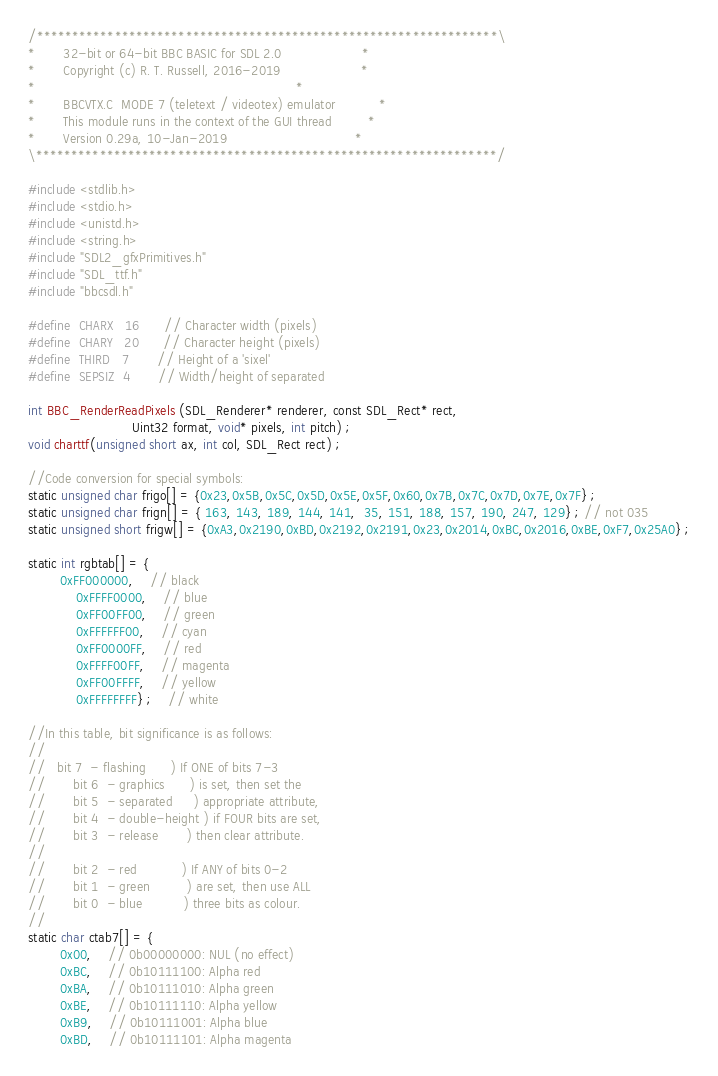<code> <loc_0><loc_0><loc_500><loc_500><_C_>/*****************************************************************\
*       32-bit or 64-bit BBC BASIC for SDL 2.0                    *
*       Copyright (c) R. T. Russell, 2016-2019                    *
*                                                                 *
*       BBCVTX.C  MODE 7 (teletext / videotex) emulator           *
*       This module runs in the context of the GUI thread         *
*       Version 0.29a, 10-Jan-2019                                *
\*****************************************************************/

#include <stdlib.h>
#include <stdio.h>
#include <unistd.h>
#include <string.h>
#include "SDL2_gfxPrimitives.h"
#include "SDL_ttf.h"
#include "bbcsdl.h"

#define	CHARX	16      // Character width (pixels)
#define	CHARY	20      // Character height (pixels)
#define	THIRD	7       // Height of a 'sixel'
#define	SEPSIZ	4       // Width/height of separated

int BBC_RenderReadPixels (SDL_Renderer* renderer, const SDL_Rect* rect,
                          Uint32 format, void* pixels, int pitch) ;
void charttf(unsigned short ax, int col, SDL_Rect rect) ;

//Code conversion for special symbols:
static unsigned char frigo[] = {0x23,0x5B,0x5C,0x5D,0x5E,0x5F,0x60,0x7B,0x7C,0x7D,0x7E,0x7F} ;
static unsigned char frign[] = { 163, 143, 189, 144, 141,  35, 151, 188, 157, 190, 247, 129} ; // not 035
static unsigned short frigw[] = {0xA3,0x2190,0xBD,0x2192,0x2191,0x23,0x2014,0xBC,0x2016,0xBE,0xF7,0x25A0} ;

static int rgbtab[] = {
		0xFF000000,	// black
        	0xFFFF0000,	// blue
        	0xFF00FF00,	// green
        	0xFFFFFF00,	// cyan
        	0xFF0000FF,	// red
        	0xFFFF00FF,	// magenta
        	0xFF00FFFF,	// yellow
        	0xFFFFFFFF} ; 	// white

//In this table, bit significance is as follows:
//
//	 bit 7  - flashing      ) If ONE of bits 7-3
//       bit 6  - graphics      ) is set, then set the
//       bit 5  - separated     ) appropriate attribute,
//       bit 4  - double-height ) if FOUR bits are set,
//       bit 3  - release       ) then clear attribute.
//
//       bit 2  - red           ) If ANY of bits 0-2
//       bit 1  - green         ) are set, then use ALL
//       bit 0  - blue          ) three bits as colour.
//
static char ctab7[] = {
		0x00,	// 0b00000000: NUL (no effect)
		0xBC,	// 0b10111100: Alpha red
		0xBA,	// 0b10111010: Alpha green
		0xBE,	// 0b10111110: Alpha yellow
		0xB9,	// 0b10111001: Alpha blue
		0xBD,	// 0b10111101: Alpha magenta</code> 